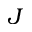<formula> <loc_0><loc_0><loc_500><loc_500>J</formula> 